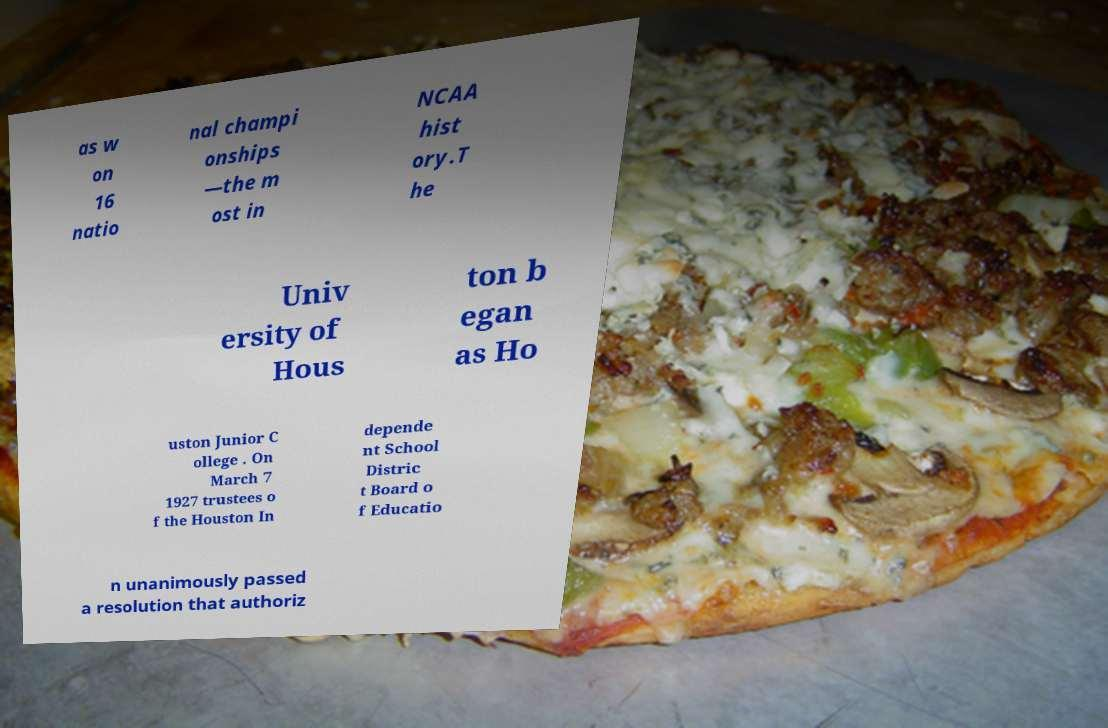Can you accurately transcribe the text from the provided image for me? as w on 16 natio nal champi onships —the m ost in NCAA hist ory.T he Univ ersity of Hous ton b egan as Ho uston Junior C ollege . On March 7 1927 trustees o f the Houston In depende nt School Distric t Board o f Educatio n unanimously passed a resolution that authoriz 